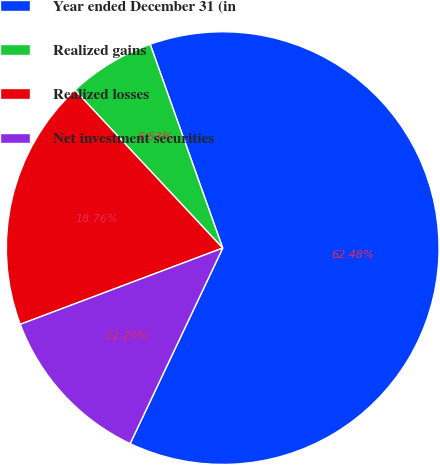<chart> <loc_0><loc_0><loc_500><loc_500><pie_chart><fcel>Year ended December 31 (in<fcel>Realized gains<fcel>Realized losses<fcel>Net investment securities<nl><fcel>62.48%<fcel>6.53%<fcel>18.76%<fcel>12.23%<nl></chart> 